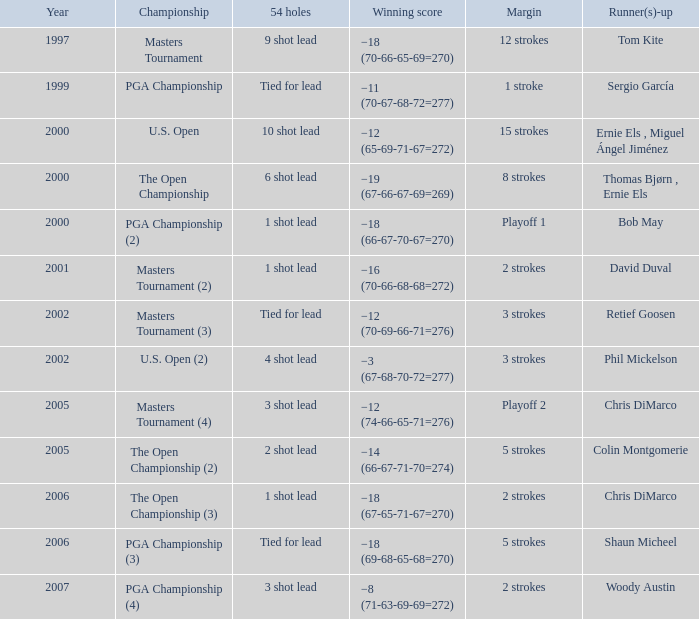 what's the 54 holes where winning score is −19 (67-66-67-69=269) 6 shot lead. Write the full table. {'header': ['Year', 'Championship', '54 holes', 'Winning score', 'Margin', 'Runner(s)-up'], 'rows': [['1997', 'Masters Tournament', '9 shot lead', '−18 (70-66-65-69=270)', '12 strokes', 'Tom Kite'], ['1999', 'PGA Championship', 'Tied for lead', '−11 (70-67-68-72=277)', '1 stroke', 'Sergio García'], ['2000', 'U.S. Open', '10 shot lead', '−12 (65-69-71-67=272)', '15 strokes', 'Ernie Els , Miguel Ángel Jiménez'], ['2000', 'The Open Championship', '6 shot lead', '−19 (67-66-67-69=269)', '8 strokes', 'Thomas Bjørn , Ernie Els'], ['2000', 'PGA Championship (2)', '1 shot lead', '−18 (66-67-70-67=270)', 'Playoff 1', 'Bob May'], ['2001', 'Masters Tournament (2)', '1 shot lead', '−16 (70-66-68-68=272)', '2 strokes', 'David Duval'], ['2002', 'Masters Tournament (3)', 'Tied for lead', '−12 (70-69-66-71=276)', '3 strokes', 'Retief Goosen'], ['2002', 'U.S. Open (2)', '4 shot lead', '−3 (67-68-70-72=277)', '3 strokes', 'Phil Mickelson'], ['2005', 'Masters Tournament (4)', '3 shot lead', '−12 (74-66-65-71=276)', 'Playoff 2', 'Chris DiMarco'], ['2005', 'The Open Championship (2)', '2 shot lead', '−14 (66-67-71-70=274)', '5 strokes', 'Colin Montgomerie'], ['2006', 'The Open Championship (3)', '1 shot lead', '−18 (67-65-71-67=270)', '2 strokes', 'Chris DiMarco'], ['2006', 'PGA Championship (3)', 'Tied for lead', '−18 (69-68-65-68=270)', '5 strokes', 'Shaun Micheel'], ['2007', 'PGA Championship (4)', '3 shot lead', '−8 (71-63-69-69=272)', '2 strokes', 'Woody Austin']]} 